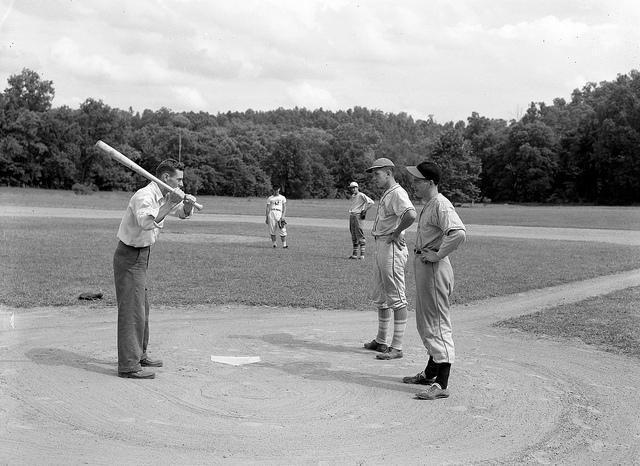How many people are there?
Give a very brief answer. 3. 